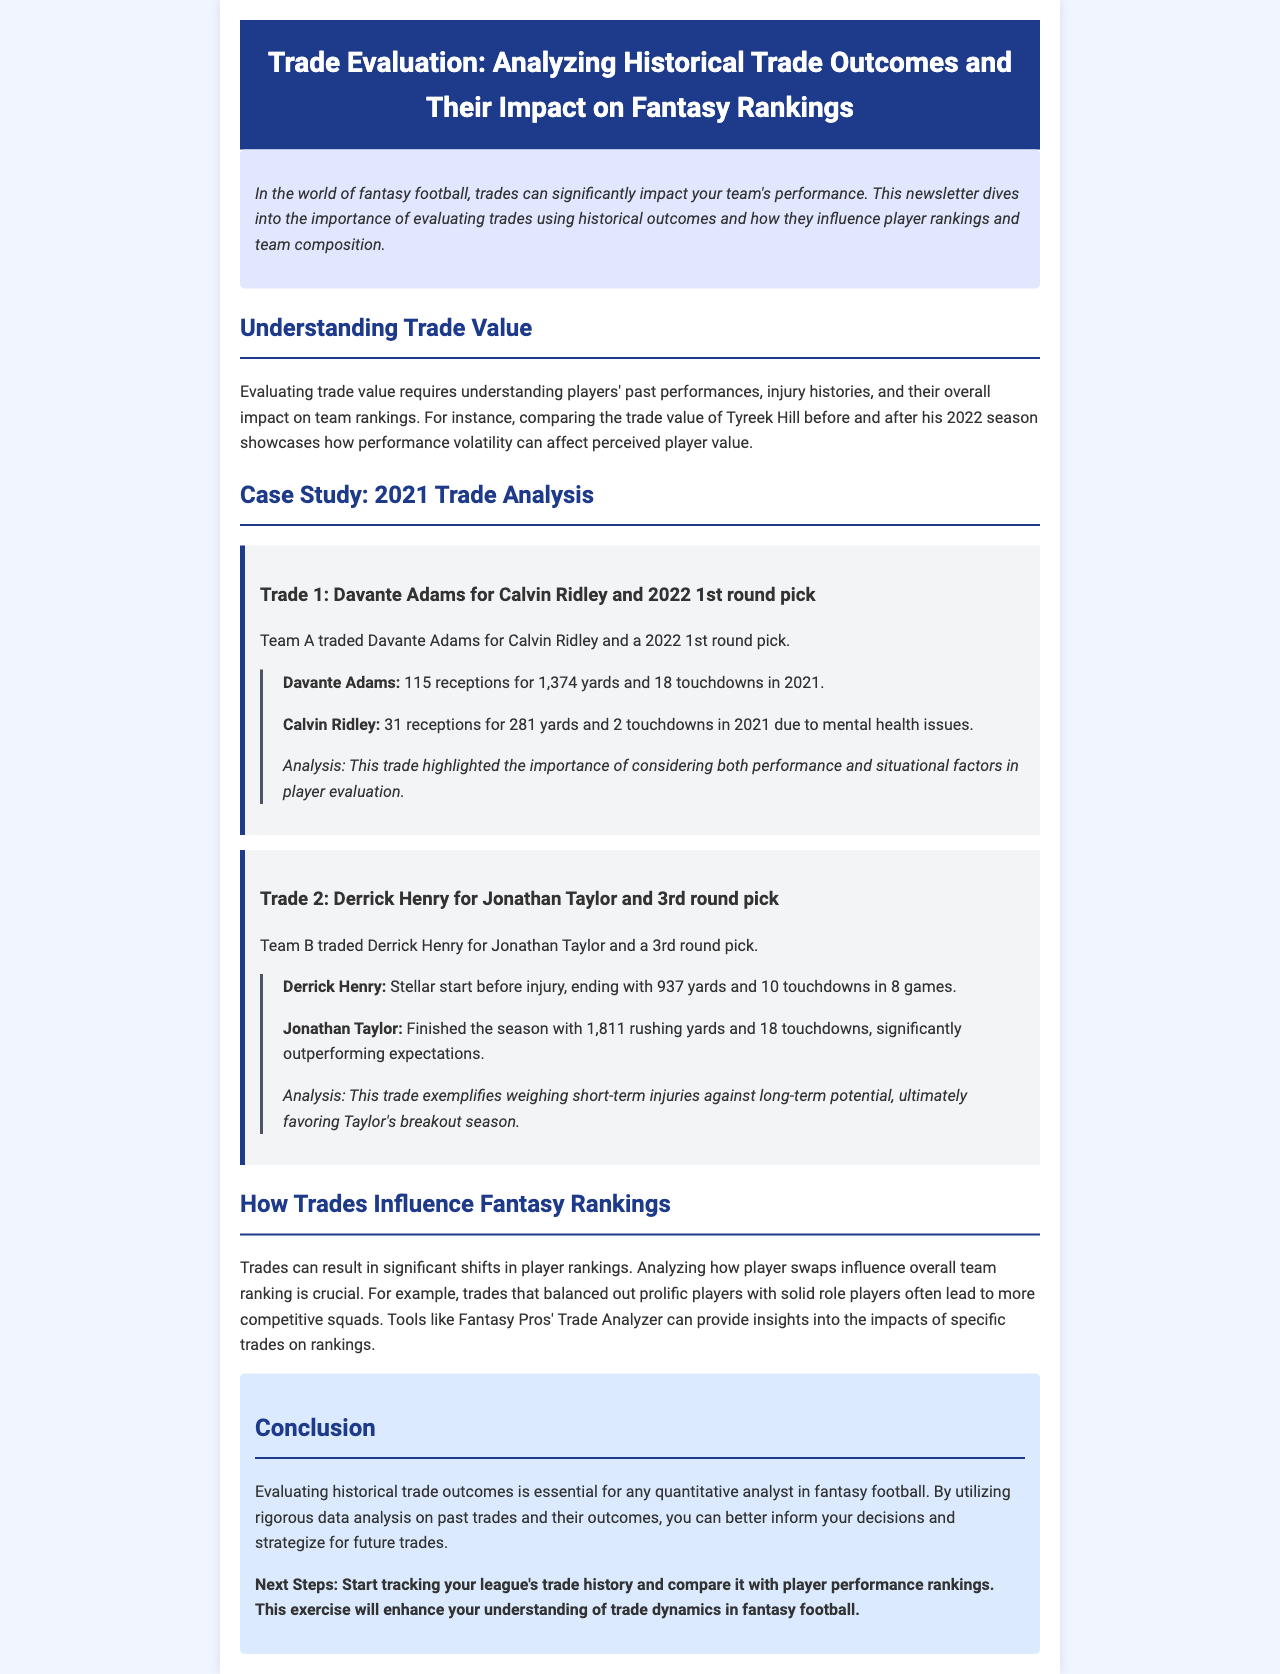what is the title of the newsletter? The title is found in the header section of the document.
Answer: Trade Evaluation: Analyzing Historical Trade Outcomes and Their Impact on Fantasy Rankings who was traded for Calvin Ridley? This is specified in the case study section about Trade 1.
Answer: Davante Adams how many rushing yards did Jonathan Taylor finish with? This figure can be found in the outcome analysis of Trade 2.
Answer: 1,811 rushing yards what influenced Calvin Ridley's 2021 performance? The document mentions specific factors affecting player outcomes in Trade 1.
Answer: Mental health issues what is the conclusion of the newsletter? The last section summarizes the insights provided throughout the document.
Answer: Evaluating historical trade outcomes is essential for any quantitative analyst in fantasy football what should readers do next according to the document? The next steps are outlined in the conclusion section for further engagement.
Answer: Start tracking your league's trade history 